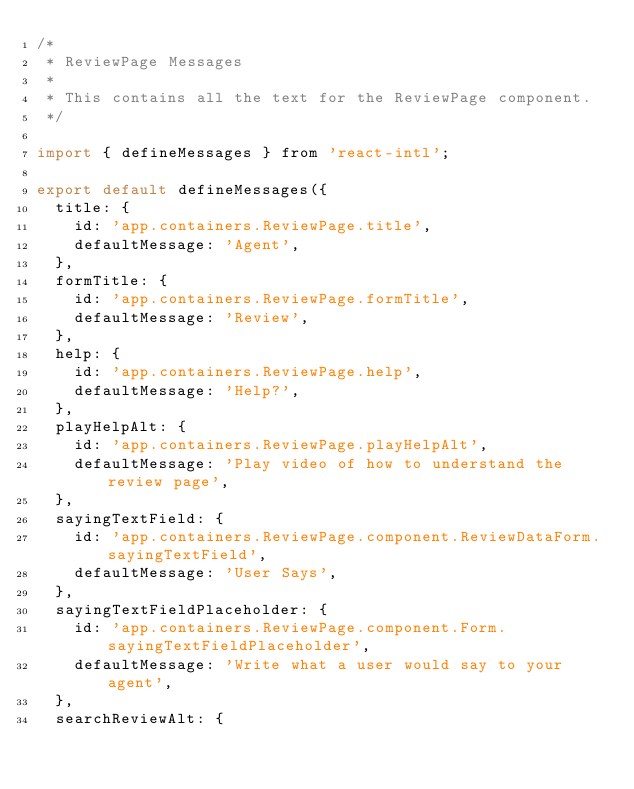Convert code to text. <code><loc_0><loc_0><loc_500><loc_500><_JavaScript_>/*
 * ReviewPage Messages
 *
 * This contains all the text for the ReviewPage component.
 */

import { defineMessages } from 'react-intl';

export default defineMessages({
  title: {
    id: 'app.containers.ReviewPage.title',
    defaultMessage: 'Agent',
  },
  formTitle: {
    id: 'app.containers.ReviewPage.formTitle',
    defaultMessage: 'Review',
  },
  help: {
    id: 'app.containers.ReviewPage.help',
    defaultMessage: 'Help?',
  },
  playHelpAlt: {
    id: 'app.containers.ReviewPage.playHelpAlt',
    defaultMessage: 'Play video of how to understand the review page',
  },
  sayingTextField: {
    id: 'app.containers.ReviewPage.component.ReviewDataForm.sayingTextField',
    defaultMessage: 'User Says',
  },
  sayingTextFieldPlaceholder: {
    id: 'app.containers.ReviewPage.component.Form.sayingTextFieldPlaceholder',
    defaultMessage: 'Write what a user would say to your agent',
  },
  searchReviewAlt: {</code> 